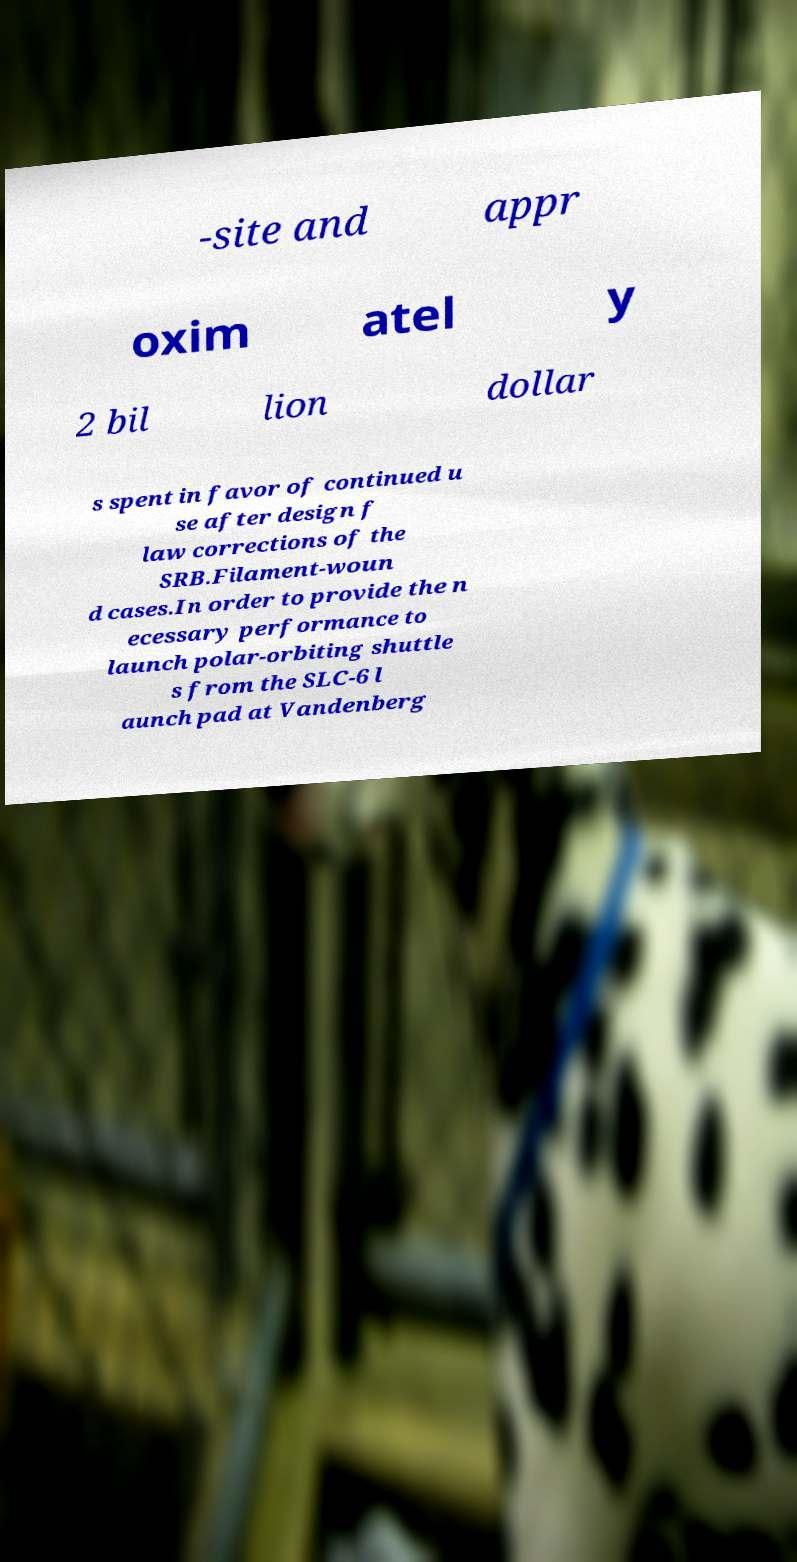Can you accurately transcribe the text from the provided image for me? -site and appr oxim atel y 2 bil lion dollar s spent in favor of continued u se after design f law corrections of the SRB.Filament-woun d cases.In order to provide the n ecessary performance to launch polar-orbiting shuttle s from the SLC-6 l aunch pad at Vandenberg 